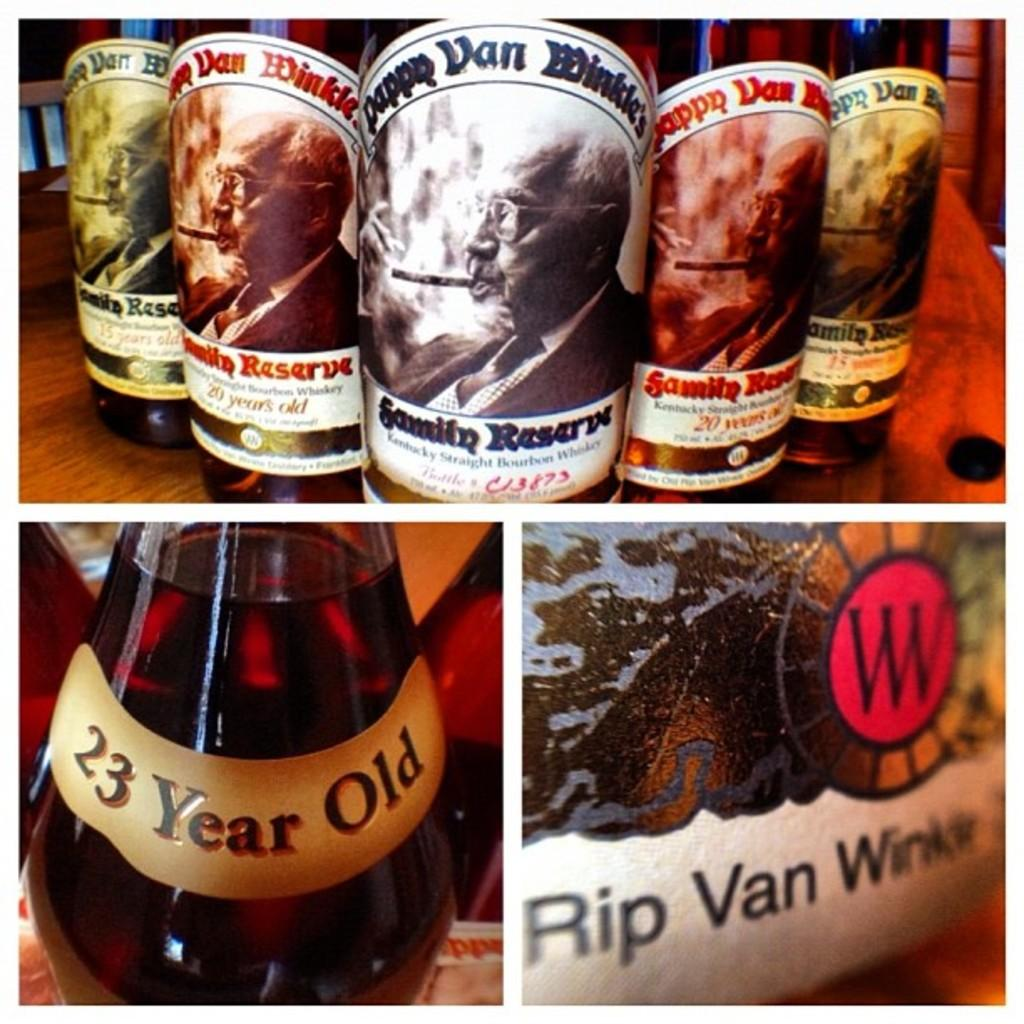What objects are on the table in the image? There are bottles on a table in the image. What type of fiction does the father write in the image? There is no father or writing activity present in the image; it only shows bottles on a table. 